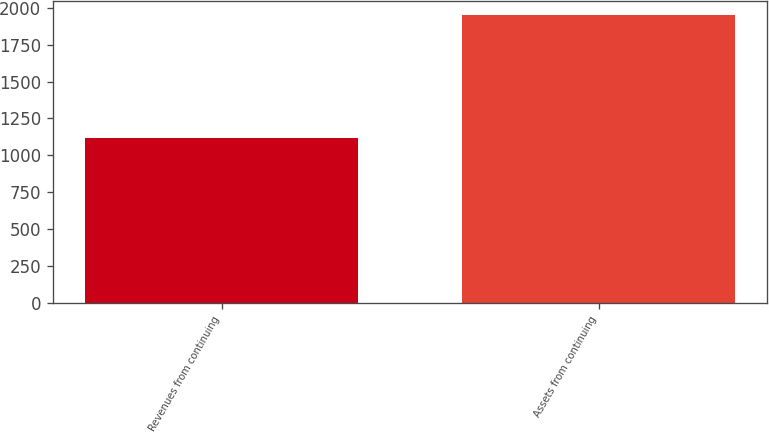Convert chart. <chart><loc_0><loc_0><loc_500><loc_500><bar_chart><fcel>Revenues from continuing<fcel>Assets from continuing<nl><fcel>1119.9<fcel>1951.3<nl></chart> 